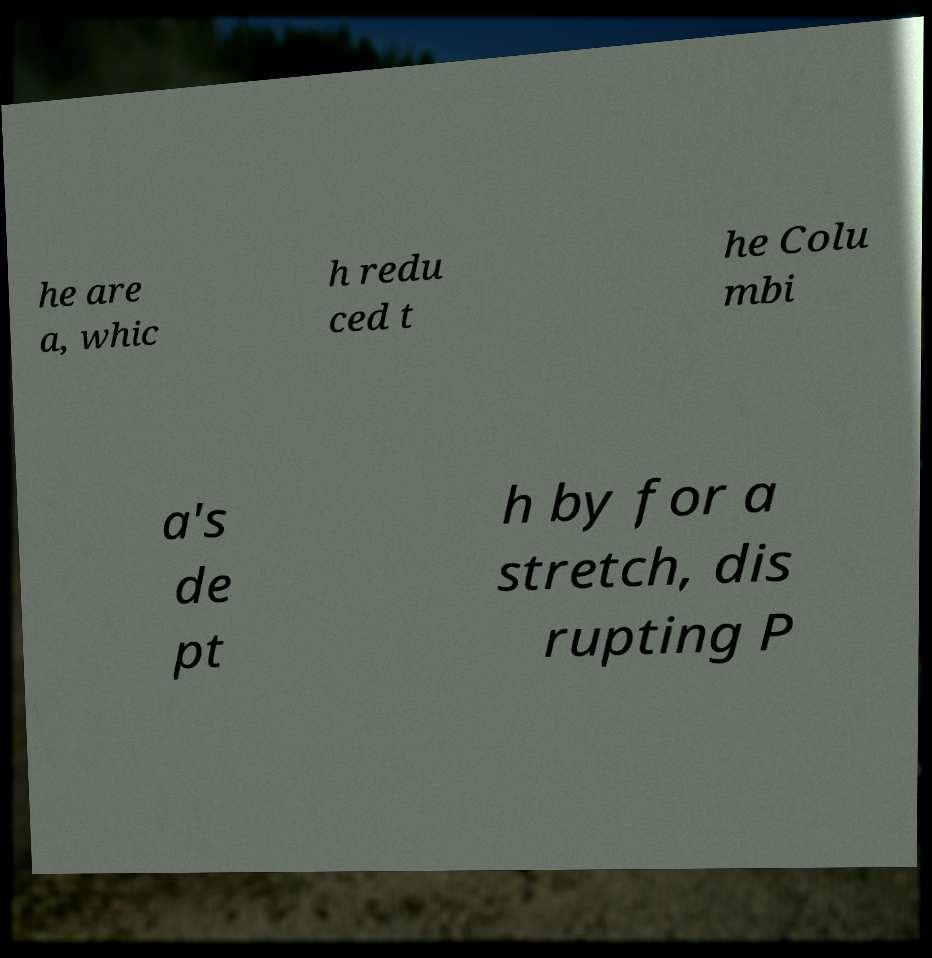Can you accurately transcribe the text from the provided image for me? he are a, whic h redu ced t he Colu mbi a's de pt h by for a stretch, dis rupting P 